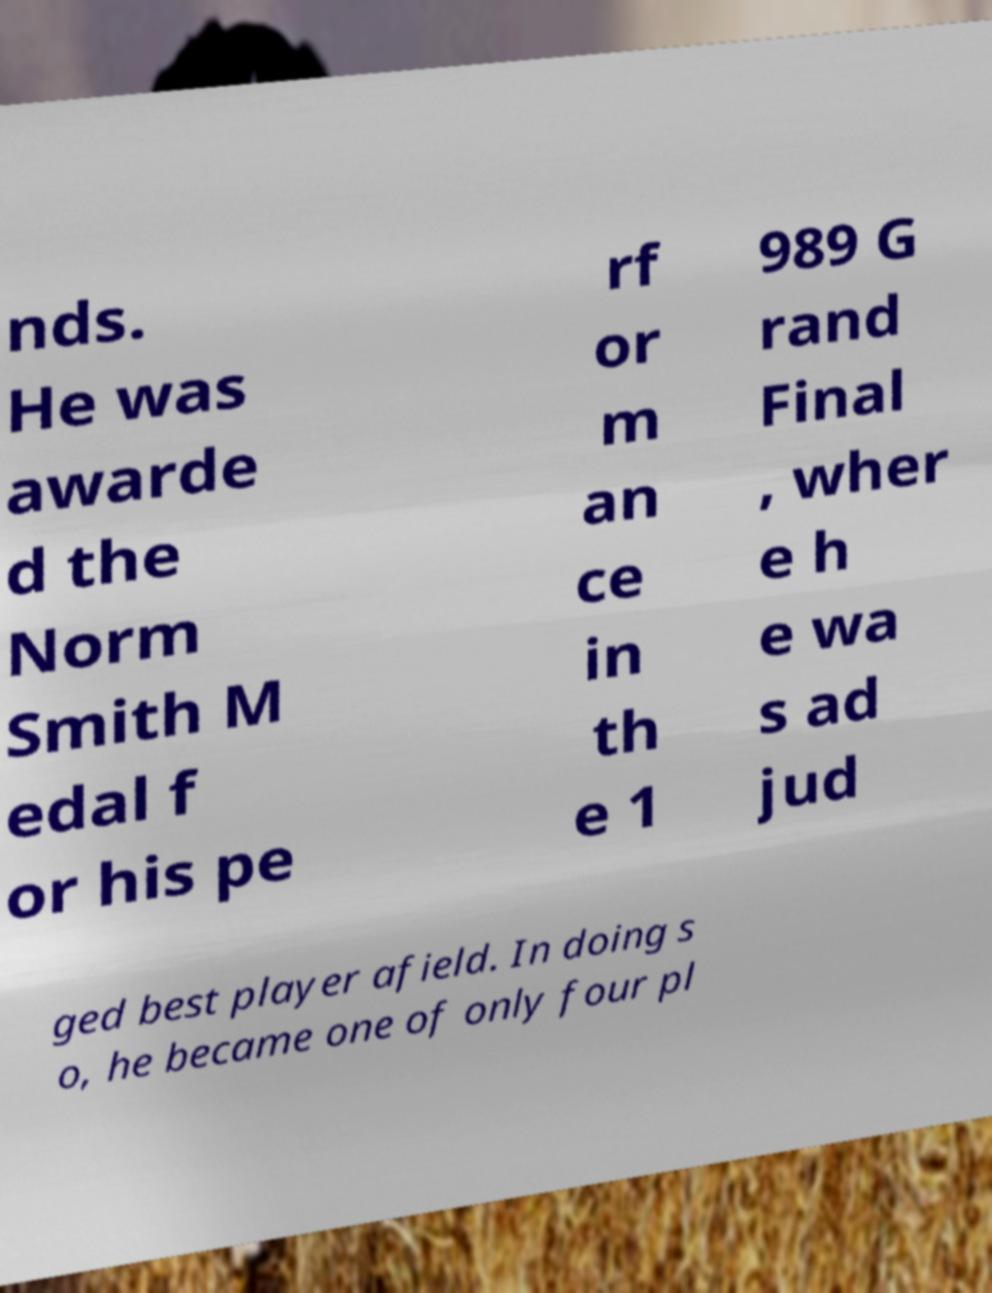Can you accurately transcribe the text from the provided image for me? nds. He was awarde d the Norm Smith M edal f or his pe rf or m an ce in th e 1 989 G rand Final , wher e h e wa s ad jud ged best player afield. In doing s o, he became one of only four pl 